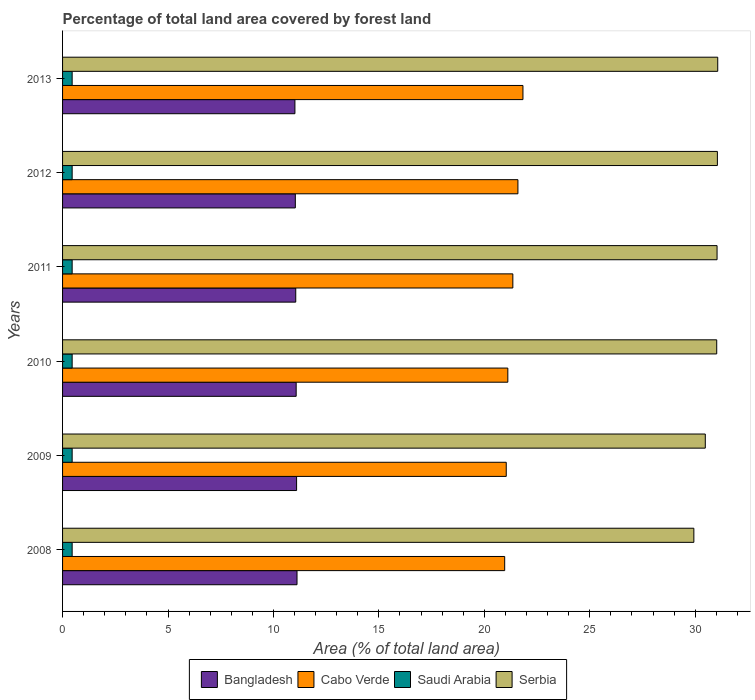How many different coloured bars are there?
Your answer should be compact. 4. How many groups of bars are there?
Provide a succinct answer. 6. Are the number of bars per tick equal to the number of legend labels?
Give a very brief answer. Yes. Are the number of bars on each tick of the Y-axis equal?
Make the answer very short. Yes. How many bars are there on the 5th tick from the top?
Make the answer very short. 4. How many bars are there on the 3rd tick from the bottom?
Keep it short and to the point. 4. In how many cases, is the number of bars for a given year not equal to the number of legend labels?
Your response must be concise. 0. What is the percentage of forest land in Serbia in 2009?
Make the answer very short. 30.48. Across all years, what is the maximum percentage of forest land in Serbia?
Give a very brief answer. 31.07. Across all years, what is the minimum percentage of forest land in Bangladesh?
Provide a succinct answer. 11.02. In which year was the percentage of forest land in Saudi Arabia maximum?
Keep it short and to the point. 2008. In which year was the percentage of forest land in Bangladesh minimum?
Your answer should be compact. 2013. What is the total percentage of forest land in Cabo Verde in the graph?
Ensure brevity in your answer.  127.9. What is the difference between the percentage of forest land in Cabo Verde in 2008 and that in 2011?
Offer a very short reply. -0.39. What is the difference between the percentage of forest land in Serbia in 2009 and the percentage of forest land in Cabo Verde in 2008?
Offer a terse response. 9.51. What is the average percentage of forest land in Bangladesh per year?
Provide a short and direct response. 11.07. In the year 2009, what is the difference between the percentage of forest land in Serbia and percentage of forest land in Cabo Verde?
Provide a short and direct response. 9.44. In how many years, is the percentage of forest land in Bangladesh greater than 20 %?
Your answer should be very brief. 0. What is the ratio of the percentage of forest land in Bangladesh in 2010 to that in 2013?
Your answer should be very brief. 1.01. Is the percentage of forest land in Serbia in 2010 less than that in 2012?
Ensure brevity in your answer.  Yes. What is the difference between the highest and the second highest percentage of forest land in Saudi Arabia?
Your answer should be very brief. 0. What is the difference between the highest and the lowest percentage of forest land in Serbia?
Your answer should be compact. 1.13. In how many years, is the percentage of forest land in Cabo Verde greater than the average percentage of forest land in Cabo Verde taken over all years?
Your answer should be very brief. 3. What does the 1st bar from the top in 2011 represents?
Your answer should be very brief. Serbia. What does the 1st bar from the bottom in 2013 represents?
Ensure brevity in your answer.  Bangladesh. How many years are there in the graph?
Offer a very short reply. 6. Are the values on the major ticks of X-axis written in scientific E-notation?
Your answer should be compact. No. Does the graph contain grids?
Provide a short and direct response. No. How many legend labels are there?
Give a very brief answer. 4. How are the legend labels stacked?
Offer a very short reply. Horizontal. What is the title of the graph?
Offer a very short reply. Percentage of total land area covered by forest land. What is the label or title of the X-axis?
Offer a terse response. Area (% of total land area). What is the label or title of the Y-axis?
Your answer should be compact. Years. What is the Area (% of total land area) of Bangladesh in 2008?
Provide a succinct answer. 11.12. What is the Area (% of total land area) in Cabo Verde in 2008?
Provide a short and direct response. 20.97. What is the Area (% of total land area) of Saudi Arabia in 2008?
Provide a succinct answer. 0.45. What is the Area (% of total land area) of Serbia in 2008?
Ensure brevity in your answer.  29.94. What is the Area (% of total land area) of Bangladesh in 2009?
Provide a succinct answer. 11.1. What is the Area (% of total land area) of Cabo Verde in 2009?
Offer a very short reply. 21.04. What is the Area (% of total land area) of Saudi Arabia in 2009?
Your answer should be compact. 0.45. What is the Area (% of total land area) of Serbia in 2009?
Offer a very short reply. 30.48. What is the Area (% of total land area) in Bangladesh in 2010?
Your response must be concise. 11.08. What is the Area (% of total land area) in Cabo Verde in 2010?
Make the answer very short. 21.11. What is the Area (% of total land area) in Saudi Arabia in 2010?
Provide a succinct answer. 0.45. What is the Area (% of total land area) in Serbia in 2010?
Provide a succinct answer. 31.02. What is the Area (% of total land area) of Bangladesh in 2011?
Provide a succinct answer. 11.06. What is the Area (% of total land area) in Cabo Verde in 2011?
Ensure brevity in your answer.  21.35. What is the Area (% of total land area) of Saudi Arabia in 2011?
Offer a terse response. 0.45. What is the Area (% of total land area) in Serbia in 2011?
Ensure brevity in your answer.  31.04. What is the Area (% of total land area) in Bangladesh in 2012?
Ensure brevity in your answer.  11.04. What is the Area (% of total land area) of Cabo Verde in 2012?
Your answer should be very brief. 21.59. What is the Area (% of total land area) in Saudi Arabia in 2012?
Offer a terse response. 0.45. What is the Area (% of total land area) in Serbia in 2012?
Ensure brevity in your answer.  31.05. What is the Area (% of total land area) in Bangladesh in 2013?
Keep it short and to the point. 11.02. What is the Area (% of total land area) in Cabo Verde in 2013?
Give a very brief answer. 21.83. What is the Area (% of total land area) in Saudi Arabia in 2013?
Make the answer very short. 0.45. What is the Area (% of total land area) in Serbia in 2013?
Provide a succinct answer. 31.07. Across all years, what is the maximum Area (% of total land area) of Bangladesh?
Your answer should be compact. 11.12. Across all years, what is the maximum Area (% of total land area) of Cabo Verde?
Your response must be concise. 21.83. Across all years, what is the maximum Area (% of total land area) of Saudi Arabia?
Keep it short and to the point. 0.45. Across all years, what is the maximum Area (% of total land area) in Serbia?
Give a very brief answer. 31.07. Across all years, what is the minimum Area (% of total land area) in Bangladesh?
Your answer should be compact. 11.02. Across all years, what is the minimum Area (% of total land area) in Cabo Verde?
Make the answer very short. 20.97. Across all years, what is the minimum Area (% of total land area) of Saudi Arabia?
Offer a very short reply. 0.45. Across all years, what is the minimum Area (% of total land area) of Serbia?
Offer a terse response. 29.94. What is the total Area (% of total land area) in Bangladesh in the graph?
Your answer should be very brief. 66.41. What is the total Area (% of total land area) of Cabo Verde in the graph?
Your response must be concise. 127.9. What is the total Area (% of total land area) of Saudi Arabia in the graph?
Keep it short and to the point. 2.73. What is the total Area (% of total land area) in Serbia in the graph?
Your answer should be compact. 184.59. What is the difference between the Area (% of total land area) of Cabo Verde in 2008 and that in 2009?
Ensure brevity in your answer.  -0.07. What is the difference between the Area (% of total land area) of Serbia in 2008 and that in 2009?
Offer a very short reply. -0.54. What is the difference between the Area (% of total land area) of Bangladesh in 2008 and that in 2010?
Your answer should be compact. 0.04. What is the difference between the Area (% of total land area) of Cabo Verde in 2008 and that in 2010?
Keep it short and to the point. -0.15. What is the difference between the Area (% of total land area) of Serbia in 2008 and that in 2010?
Your response must be concise. -1.08. What is the difference between the Area (% of total land area) of Bangladesh in 2008 and that in 2011?
Your answer should be very brief. 0.06. What is the difference between the Area (% of total land area) of Cabo Verde in 2008 and that in 2011?
Your answer should be compact. -0.39. What is the difference between the Area (% of total land area) in Saudi Arabia in 2008 and that in 2011?
Make the answer very short. 0. What is the difference between the Area (% of total land area) in Serbia in 2008 and that in 2011?
Offer a terse response. -1.1. What is the difference between the Area (% of total land area) of Bangladesh in 2008 and that in 2012?
Keep it short and to the point. 0.08. What is the difference between the Area (% of total land area) in Cabo Verde in 2008 and that in 2012?
Your answer should be very brief. -0.63. What is the difference between the Area (% of total land area) in Saudi Arabia in 2008 and that in 2012?
Provide a short and direct response. 0. What is the difference between the Area (% of total land area) in Serbia in 2008 and that in 2012?
Provide a short and direct response. -1.12. What is the difference between the Area (% of total land area) in Bangladesh in 2008 and that in 2013?
Ensure brevity in your answer.  0.1. What is the difference between the Area (% of total land area) in Cabo Verde in 2008 and that in 2013?
Your answer should be compact. -0.87. What is the difference between the Area (% of total land area) in Serbia in 2008 and that in 2013?
Provide a succinct answer. -1.13. What is the difference between the Area (% of total land area) of Bangladesh in 2009 and that in 2010?
Your answer should be very brief. 0.02. What is the difference between the Area (% of total land area) of Cabo Verde in 2009 and that in 2010?
Your answer should be compact. -0.07. What is the difference between the Area (% of total land area) in Serbia in 2009 and that in 2010?
Provide a short and direct response. -0.54. What is the difference between the Area (% of total land area) of Bangladesh in 2009 and that in 2011?
Your answer should be compact. 0.04. What is the difference between the Area (% of total land area) of Cabo Verde in 2009 and that in 2011?
Offer a terse response. -0.31. What is the difference between the Area (% of total land area) of Saudi Arabia in 2009 and that in 2011?
Your answer should be very brief. 0. What is the difference between the Area (% of total land area) in Serbia in 2009 and that in 2011?
Give a very brief answer. -0.56. What is the difference between the Area (% of total land area) in Bangladesh in 2009 and that in 2012?
Provide a succinct answer. 0.06. What is the difference between the Area (% of total land area) of Cabo Verde in 2009 and that in 2012?
Your answer should be very brief. -0.55. What is the difference between the Area (% of total land area) of Serbia in 2009 and that in 2012?
Your response must be concise. -0.57. What is the difference between the Area (% of total land area) in Bangladesh in 2009 and that in 2013?
Keep it short and to the point. 0.08. What is the difference between the Area (% of total land area) in Cabo Verde in 2009 and that in 2013?
Your answer should be very brief. -0.79. What is the difference between the Area (% of total land area) of Serbia in 2009 and that in 2013?
Your answer should be very brief. -0.59. What is the difference between the Area (% of total land area) of Cabo Verde in 2010 and that in 2011?
Offer a very short reply. -0.24. What is the difference between the Area (% of total land area) of Serbia in 2010 and that in 2011?
Your response must be concise. -0.02. What is the difference between the Area (% of total land area) in Bangladesh in 2010 and that in 2012?
Offer a very short reply. 0.04. What is the difference between the Area (% of total land area) in Cabo Verde in 2010 and that in 2012?
Your answer should be very brief. -0.48. What is the difference between the Area (% of total land area) in Serbia in 2010 and that in 2012?
Ensure brevity in your answer.  -0.03. What is the difference between the Area (% of total land area) in Bangladesh in 2010 and that in 2013?
Provide a short and direct response. 0.06. What is the difference between the Area (% of total land area) in Cabo Verde in 2010 and that in 2013?
Make the answer very short. -0.72. What is the difference between the Area (% of total land area) in Saudi Arabia in 2010 and that in 2013?
Your response must be concise. 0. What is the difference between the Area (% of total land area) of Serbia in 2010 and that in 2013?
Keep it short and to the point. -0.05. What is the difference between the Area (% of total land area) of Bangladesh in 2011 and that in 2012?
Offer a very short reply. 0.02. What is the difference between the Area (% of total land area) in Cabo Verde in 2011 and that in 2012?
Provide a short and direct response. -0.24. What is the difference between the Area (% of total land area) of Saudi Arabia in 2011 and that in 2012?
Keep it short and to the point. 0. What is the difference between the Area (% of total land area) of Serbia in 2011 and that in 2012?
Make the answer very short. -0.02. What is the difference between the Area (% of total land area) of Bangladesh in 2011 and that in 2013?
Provide a short and direct response. 0.04. What is the difference between the Area (% of total land area) in Cabo Verde in 2011 and that in 2013?
Your answer should be compact. -0.48. What is the difference between the Area (% of total land area) in Saudi Arabia in 2011 and that in 2013?
Provide a short and direct response. 0. What is the difference between the Area (% of total land area) of Serbia in 2011 and that in 2013?
Offer a terse response. -0.03. What is the difference between the Area (% of total land area) in Bangladesh in 2012 and that in 2013?
Offer a terse response. 0.02. What is the difference between the Area (% of total land area) in Cabo Verde in 2012 and that in 2013?
Your response must be concise. -0.24. What is the difference between the Area (% of total land area) in Saudi Arabia in 2012 and that in 2013?
Your response must be concise. 0. What is the difference between the Area (% of total land area) in Serbia in 2012 and that in 2013?
Your response must be concise. -0.02. What is the difference between the Area (% of total land area) in Bangladesh in 2008 and the Area (% of total land area) in Cabo Verde in 2009?
Give a very brief answer. -9.92. What is the difference between the Area (% of total land area) of Bangladesh in 2008 and the Area (% of total land area) of Saudi Arabia in 2009?
Ensure brevity in your answer.  10.66. What is the difference between the Area (% of total land area) of Bangladesh in 2008 and the Area (% of total land area) of Serbia in 2009?
Your answer should be very brief. -19.36. What is the difference between the Area (% of total land area) of Cabo Verde in 2008 and the Area (% of total land area) of Saudi Arabia in 2009?
Ensure brevity in your answer.  20.51. What is the difference between the Area (% of total land area) in Cabo Verde in 2008 and the Area (% of total land area) in Serbia in 2009?
Offer a very short reply. -9.51. What is the difference between the Area (% of total land area) of Saudi Arabia in 2008 and the Area (% of total land area) of Serbia in 2009?
Keep it short and to the point. -30.02. What is the difference between the Area (% of total land area) of Bangladesh in 2008 and the Area (% of total land area) of Cabo Verde in 2010?
Offer a terse response. -10. What is the difference between the Area (% of total land area) of Bangladesh in 2008 and the Area (% of total land area) of Saudi Arabia in 2010?
Provide a succinct answer. 10.66. What is the difference between the Area (% of total land area) in Bangladesh in 2008 and the Area (% of total land area) in Serbia in 2010?
Provide a succinct answer. -19.9. What is the difference between the Area (% of total land area) of Cabo Verde in 2008 and the Area (% of total land area) of Saudi Arabia in 2010?
Your answer should be very brief. 20.51. What is the difference between the Area (% of total land area) of Cabo Verde in 2008 and the Area (% of total land area) of Serbia in 2010?
Keep it short and to the point. -10.05. What is the difference between the Area (% of total land area) of Saudi Arabia in 2008 and the Area (% of total land area) of Serbia in 2010?
Provide a succinct answer. -30.57. What is the difference between the Area (% of total land area) of Bangladesh in 2008 and the Area (% of total land area) of Cabo Verde in 2011?
Make the answer very short. -10.23. What is the difference between the Area (% of total land area) of Bangladesh in 2008 and the Area (% of total land area) of Saudi Arabia in 2011?
Your answer should be compact. 10.66. What is the difference between the Area (% of total land area) in Bangladesh in 2008 and the Area (% of total land area) in Serbia in 2011?
Ensure brevity in your answer.  -19.92. What is the difference between the Area (% of total land area) in Cabo Verde in 2008 and the Area (% of total land area) in Saudi Arabia in 2011?
Your response must be concise. 20.51. What is the difference between the Area (% of total land area) in Cabo Verde in 2008 and the Area (% of total land area) in Serbia in 2011?
Give a very brief answer. -10.07. What is the difference between the Area (% of total land area) of Saudi Arabia in 2008 and the Area (% of total land area) of Serbia in 2011?
Your answer should be compact. -30.58. What is the difference between the Area (% of total land area) of Bangladesh in 2008 and the Area (% of total land area) of Cabo Verde in 2012?
Your answer should be compact. -10.48. What is the difference between the Area (% of total land area) in Bangladesh in 2008 and the Area (% of total land area) in Saudi Arabia in 2012?
Give a very brief answer. 10.66. What is the difference between the Area (% of total land area) of Bangladesh in 2008 and the Area (% of total land area) of Serbia in 2012?
Your response must be concise. -19.93. What is the difference between the Area (% of total land area) in Cabo Verde in 2008 and the Area (% of total land area) in Saudi Arabia in 2012?
Provide a succinct answer. 20.51. What is the difference between the Area (% of total land area) of Cabo Verde in 2008 and the Area (% of total land area) of Serbia in 2012?
Offer a terse response. -10.09. What is the difference between the Area (% of total land area) in Saudi Arabia in 2008 and the Area (% of total land area) in Serbia in 2012?
Your response must be concise. -30.6. What is the difference between the Area (% of total land area) in Bangladesh in 2008 and the Area (% of total land area) in Cabo Verde in 2013?
Provide a short and direct response. -10.71. What is the difference between the Area (% of total land area) in Bangladesh in 2008 and the Area (% of total land area) in Saudi Arabia in 2013?
Provide a succinct answer. 10.66. What is the difference between the Area (% of total land area) of Bangladesh in 2008 and the Area (% of total land area) of Serbia in 2013?
Offer a terse response. -19.95. What is the difference between the Area (% of total land area) of Cabo Verde in 2008 and the Area (% of total land area) of Saudi Arabia in 2013?
Your response must be concise. 20.51. What is the difference between the Area (% of total land area) of Cabo Verde in 2008 and the Area (% of total land area) of Serbia in 2013?
Provide a short and direct response. -10.1. What is the difference between the Area (% of total land area) of Saudi Arabia in 2008 and the Area (% of total land area) of Serbia in 2013?
Provide a succinct answer. -30.61. What is the difference between the Area (% of total land area) in Bangladesh in 2009 and the Area (% of total land area) in Cabo Verde in 2010?
Provide a succinct answer. -10.02. What is the difference between the Area (% of total land area) in Bangladesh in 2009 and the Area (% of total land area) in Saudi Arabia in 2010?
Make the answer very short. 10.64. What is the difference between the Area (% of total land area) of Bangladesh in 2009 and the Area (% of total land area) of Serbia in 2010?
Make the answer very short. -19.92. What is the difference between the Area (% of total land area) in Cabo Verde in 2009 and the Area (% of total land area) in Saudi Arabia in 2010?
Give a very brief answer. 20.59. What is the difference between the Area (% of total land area) of Cabo Verde in 2009 and the Area (% of total land area) of Serbia in 2010?
Provide a succinct answer. -9.98. What is the difference between the Area (% of total land area) in Saudi Arabia in 2009 and the Area (% of total land area) in Serbia in 2010?
Offer a very short reply. -30.57. What is the difference between the Area (% of total land area) of Bangladesh in 2009 and the Area (% of total land area) of Cabo Verde in 2011?
Give a very brief answer. -10.25. What is the difference between the Area (% of total land area) in Bangladesh in 2009 and the Area (% of total land area) in Saudi Arabia in 2011?
Offer a very short reply. 10.64. What is the difference between the Area (% of total land area) in Bangladesh in 2009 and the Area (% of total land area) in Serbia in 2011?
Your response must be concise. -19.94. What is the difference between the Area (% of total land area) in Cabo Verde in 2009 and the Area (% of total land area) in Saudi Arabia in 2011?
Your answer should be compact. 20.59. What is the difference between the Area (% of total land area) of Cabo Verde in 2009 and the Area (% of total land area) of Serbia in 2011?
Ensure brevity in your answer.  -10. What is the difference between the Area (% of total land area) of Saudi Arabia in 2009 and the Area (% of total land area) of Serbia in 2011?
Your answer should be very brief. -30.58. What is the difference between the Area (% of total land area) in Bangladesh in 2009 and the Area (% of total land area) in Cabo Verde in 2012?
Provide a succinct answer. -10.5. What is the difference between the Area (% of total land area) of Bangladesh in 2009 and the Area (% of total land area) of Saudi Arabia in 2012?
Offer a terse response. 10.64. What is the difference between the Area (% of total land area) in Bangladesh in 2009 and the Area (% of total land area) in Serbia in 2012?
Ensure brevity in your answer.  -19.95. What is the difference between the Area (% of total land area) of Cabo Verde in 2009 and the Area (% of total land area) of Saudi Arabia in 2012?
Your answer should be very brief. 20.59. What is the difference between the Area (% of total land area) in Cabo Verde in 2009 and the Area (% of total land area) in Serbia in 2012?
Offer a very short reply. -10.01. What is the difference between the Area (% of total land area) in Saudi Arabia in 2009 and the Area (% of total land area) in Serbia in 2012?
Provide a succinct answer. -30.6. What is the difference between the Area (% of total land area) in Bangladesh in 2009 and the Area (% of total land area) in Cabo Verde in 2013?
Provide a short and direct response. -10.73. What is the difference between the Area (% of total land area) in Bangladesh in 2009 and the Area (% of total land area) in Saudi Arabia in 2013?
Provide a succinct answer. 10.64. What is the difference between the Area (% of total land area) of Bangladesh in 2009 and the Area (% of total land area) of Serbia in 2013?
Offer a very short reply. -19.97. What is the difference between the Area (% of total land area) in Cabo Verde in 2009 and the Area (% of total land area) in Saudi Arabia in 2013?
Provide a short and direct response. 20.59. What is the difference between the Area (% of total land area) of Cabo Verde in 2009 and the Area (% of total land area) of Serbia in 2013?
Keep it short and to the point. -10.03. What is the difference between the Area (% of total land area) of Saudi Arabia in 2009 and the Area (% of total land area) of Serbia in 2013?
Make the answer very short. -30.61. What is the difference between the Area (% of total land area) in Bangladesh in 2010 and the Area (% of total land area) in Cabo Verde in 2011?
Ensure brevity in your answer.  -10.27. What is the difference between the Area (% of total land area) in Bangladesh in 2010 and the Area (% of total land area) in Saudi Arabia in 2011?
Make the answer very short. 10.62. What is the difference between the Area (% of total land area) of Bangladesh in 2010 and the Area (% of total land area) of Serbia in 2011?
Offer a terse response. -19.96. What is the difference between the Area (% of total land area) of Cabo Verde in 2010 and the Area (% of total land area) of Saudi Arabia in 2011?
Make the answer very short. 20.66. What is the difference between the Area (% of total land area) in Cabo Verde in 2010 and the Area (% of total land area) in Serbia in 2011?
Provide a short and direct response. -9.92. What is the difference between the Area (% of total land area) of Saudi Arabia in 2010 and the Area (% of total land area) of Serbia in 2011?
Give a very brief answer. -30.58. What is the difference between the Area (% of total land area) in Bangladesh in 2010 and the Area (% of total land area) in Cabo Verde in 2012?
Keep it short and to the point. -10.52. What is the difference between the Area (% of total land area) in Bangladesh in 2010 and the Area (% of total land area) in Saudi Arabia in 2012?
Provide a short and direct response. 10.62. What is the difference between the Area (% of total land area) in Bangladesh in 2010 and the Area (% of total land area) in Serbia in 2012?
Your response must be concise. -19.97. What is the difference between the Area (% of total land area) in Cabo Verde in 2010 and the Area (% of total land area) in Saudi Arabia in 2012?
Give a very brief answer. 20.66. What is the difference between the Area (% of total land area) of Cabo Verde in 2010 and the Area (% of total land area) of Serbia in 2012?
Provide a short and direct response. -9.94. What is the difference between the Area (% of total land area) in Saudi Arabia in 2010 and the Area (% of total land area) in Serbia in 2012?
Offer a very short reply. -30.6. What is the difference between the Area (% of total land area) in Bangladesh in 2010 and the Area (% of total land area) in Cabo Verde in 2013?
Your answer should be very brief. -10.75. What is the difference between the Area (% of total land area) of Bangladesh in 2010 and the Area (% of total land area) of Saudi Arabia in 2013?
Your answer should be compact. 10.62. What is the difference between the Area (% of total land area) in Bangladesh in 2010 and the Area (% of total land area) in Serbia in 2013?
Offer a very short reply. -19.99. What is the difference between the Area (% of total land area) in Cabo Verde in 2010 and the Area (% of total land area) in Saudi Arabia in 2013?
Provide a succinct answer. 20.66. What is the difference between the Area (% of total land area) in Cabo Verde in 2010 and the Area (% of total land area) in Serbia in 2013?
Provide a short and direct response. -9.95. What is the difference between the Area (% of total land area) in Saudi Arabia in 2010 and the Area (% of total land area) in Serbia in 2013?
Provide a succinct answer. -30.61. What is the difference between the Area (% of total land area) in Bangladesh in 2011 and the Area (% of total land area) in Cabo Verde in 2012?
Make the answer very short. -10.54. What is the difference between the Area (% of total land area) in Bangladesh in 2011 and the Area (% of total land area) in Saudi Arabia in 2012?
Your answer should be very brief. 10.6. What is the difference between the Area (% of total land area) of Bangladesh in 2011 and the Area (% of total land area) of Serbia in 2012?
Make the answer very short. -19.99. What is the difference between the Area (% of total land area) in Cabo Verde in 2011 and the Area (% of total land area) in Saudi Arabia in 2012?
Your answer should be compact. 20.9. What is the difference between the Area (% of total land area) of Cabo Verde in 2011 and the Area (% of total land area) of Serbia in 2012?
Your response must be concise. -9.7. What is the difference between the Area (% of total land area) of Saudi Arabia in 2011 and the Area (% of total land area) of Serbia in 2012?
Make the answer very short. -30.6. What is the difference between the Area (% of total land area) in Bangladesh in 2011 and the Area (% of total land area) in Cabo Verde in 2013?
Give a very brief answer. -10.77. What is the difference between the Area (% of total land area) in Bangladesh in 2011 and the Area (% of total land area) in Saudi Arabia in 2013?
Make the answer very short. 10.6. What is the difference between the Area (% of total land area) of Bangladesh in 2011 and the Area (% of total land area) of Serbia in 2013?
Ensure brevity in your answer.  -20.01. What is the difference between the Area (% of total land area) of Cabo Verde in 2011 and the Area (% of total land area) of Saudi Arabia in 2013?
Keep it short and to the point. 20.9. What is the difference between the Area (% of total land area) in Cabo Verde in 2011 and the Area (% of total land area) in Serbia in 2013?
Your answer should be very brief. -9.72. What is the difference between the Area (% of total land area) of Saudi Arabia in 2011 and the Area (% of total land area) of Serbia in 2013?
Provide a succinct answer. -30.61. What is the difference between the Area (% of total land area) of Bangladesh in 2012 and the Area (% of total land area) of Cabo Verde in 2013?
Provide a short and direct response. -10.79. What is the difference between the Area (% of total land area) in Bangladesh in 2012 and the Area (% of total land area) in Saudi Arabia in 2013?
Keep it short and to the point. 10.58. What is the difference between the Area (% of total land area) of Bangladesh in 2012 and the Area (% of total land area) of Serbia in 2013?
Offer a very short reply. -20.03. What is the difference between the Area (% of total land area) in Cabo Verde in 2012 and the Area (% of total land area) in Saudi Arabia in 2013?
Provide a short and direct response. 21.14. What is the difference between the Area (% of total land area) in Cabo Verde in 2012 and the Area (% of total land area) in Serbia in 2013?
Your answer should be compact. -9.47. What is the difference between the Area (% of total land area) in Saudi Arabia in 2012 and the Area (% of total land area) in Serbia in 2013?
Your answer should be compact. -30.61. What is the average Area (% of total land area) in Bangladesh per year?
Offer a terse response. 11.07. What is the average Area (% of total land area) of Cabo Verde per year?
Your answer should be compact. 21.32. What is the average Area (% of total land area) of Saudi Arabia per year?
Ensure brevity in your answer.  0.45. What is the average Area (% of total land area) of Serbia per year?
Ensure brevity in your answer.  30.76. In the year 2008, what is the difference between the Area (% of total land area) in Bangladesh and Area (% of total land area) in Cabo Verde?
Ensure brevity in your answer.  -9.85. In the year 2008, what is the difference between the Area (% of total land area) in Bangladesh and Area (% of total land area) in Saudi Arabia?
Keep it short and to the point. 10.66. In the year 2008, what is the difference between the Area (% of total land area) in Bangladesh and Area (% of total land area) in Serbia?
Provide a succinct answer. -18.82. In the year 2008, what is the difference between the Area (% of total land area) of Cabo Verde and Area (% of total land area) of Saudi Arabia?
Make the answer very short. 20.51. In the year 2008, what is the difference between the Area (% of total land area) of Cabo Verde and Area (% of total land area) of Serbia?
Provide a short and direct response. -8.97. In the year 2008, what is the difference between the Area (% of total land area) of Saudi Arabia and Area (% of total land area) of Serbia?
Offer a terse response. -29.48. In the year 2009, what is the difference between the Area (% of total land area) of Bangladesh and Area (% of total land area) of Cabo Verde?
Make the answer very short. -9.94. In the year 2009, what is the difference between the Area (% of total land area) of Bangladesh and Area (% of total land area) of Saudi Arabia?
Offer a very short reply. 10.64. In the year 2009, what is the difference between the Area (% of total land area) of Bangladesh and Area (% of total land area) of Serbia?
Your response must be concise. -19.38. In the year 2009, what is the difference between the Area (% of total land area) in Cabo Verde and Area (% of total land area) in Saudi Arabia?
Offer a very short reply. 20.59. In the year 2009, what is the difference between the Area (% of total land area) in Cabo Verde and Area (% of total land area) in Serbia?
Make the answer very short. -9.44. In the year 2009, what is the difference between the Area (% of total land area) in Saudi Arabia and Area (% of total land area) in Serbia?
Offer a very short reply. -30.02. In the year 2010, what is the difference between the Area (% of total land area) in Bangladesh and Area (% of total land area) in Cabo Verde?
Offer a terse response. -10.04. In the year 2010, what is the difference between the Area (% of total land area) in Bangladesh and Area (% of total land area) in Saudi Arabia?
Make the answer very short. 10.62. In the year 2010, what is the difference between the Area (% of total land area) in Bangladesh and Area (% of total land area) in Serbia?
Offer a terse response. -19.94. In the year 2010, what is the difference between the Area (% of total land area) in Cabo Verde and Area (% of total land area) in Saudi Arabia?
Provide a short and direct response. 20.66. In the year 2010, what is the difference between the Area (% of total land area) of Cabo Verde and Area (% of total land area) of Serbia?
Your response must be concise. -9.91. In the year 2010, what is the difference between the Area (% of total land area) of Saudi Arabia and Area (% of total land area) of Serbia?
Give a very brief answer. -30.57. In the year 2011, what is the difference between the Area (% of total land area) in Bangladesh and Area (% of total land area) in Cabo Verde?
Your answer should be compact. -10.29. In the year 2011, what is the difference between the Area (% of total land area) of Bangladesh and Area (% of total land area) of Saudi Arabia?
Make the answer very short. 10.6. In the year 2011, what is the difference between the Area (% of total land area) in Bangladesh and Area (% of total land area) in Serbia?
Offer a terse response. -19.98. In the year 2011, what is the difference between the Area (% of total land area) in Cabo Verde and Area (% of total land area) in Saudi Arabia?
Ensure brevity in your answer.  20.9. In the year 2011, what is the difference between the Area (% of total land area) in Cabo Verde and Area (% of total land area) in Serbia?
Provide a short and direct response. -9.68. In the year 2011, what is the difference between the Area (% of total land area) in Saudi Arabia and Area (% of total land area) in Serbia?
Give a very brief answer. -30.58. In the year 2012, what is the difference between the Area (% of total land area) in Bangladesh and Area (% of total land area) in Cabo Verde?
Make the answer very short. -10.56. In the year 2012, what is the difference between the Area (% of total land area) in Bangladesh and Area (% of total land area) in Saudi Arabia?
Provide a short and direct response. 10.58. In the year 2012, what is the difference between the Area (% of total land area) in Bangladesh and Area (% of total land area) in Serbia?
Keep it short and to the point. -20.01. In the year 2012, what is the difference between the Area (% of total land area) of Cabo Verde and Area (% of total land area) of Saudi Arabia?
Offer a very short reply. 21.14. In the year 2012, what is the difference between the Area (% of total land area) in Cabo Verde and Area (% of total land area) in Serbia?
Provide a succinct answer. -9.46. In the year 2012, what is the difference between the Area (% of total land area) of Saudi Arabia and Area (% of total land area) of Serbia?
Make the answer very short. -30.6. In the year 2013, what is the difference between the Area (% of total land area) in Bangladesh and Area (% of total land area) in Cabo Verde?
Your answer should be compact. -10.81. In the year 2013, what is the difference between the Area (% of total land area) of Bangladesh and Area (% of total land area) of Saudi Arabia?
Your answer should be very brief. 10.56. In the year 2013, what is the difference between the Area (% of total land area) of Bangladesh and Area (% of total land area) of Serbia?
Provide a short and direct response. -20.05. In the year 2013, what is the difference between the Area (% of total land area) in Cabo Verde and Area (% of total land area) in Saudi Arabia?
Offer a very short reply. 21.38. In the year 2013, what is the difference between the Area (% of total land area) in Cabo Verde and Area (% of total land area) in Serbia?
Provide a succinct answer. -9.24. In the year 2013, what is the difference between the Area (% of total land area) in Saudi Arabia and Area (% of total land area) in Serbia?
Your response must be concise. -30.61. What is the ratio of the Area (% of total land area) in Bangladesh in 2008 to that in 2009?
Give a very brief answer. 1. What is the ratio of the Area (% of total land area) in Cabo Verde in 2008 to that in 2009?
Give a very brief answer. 1. What is the ratio of the Area (% of total land area) in Saudi Arabia in 2008 to that in 2009?
Provide a succinct answer. 1. What is the ratio of the Area (% of total land area) in Serbia in 2008 to that in 2009?
Your answer should be very brief. 0.98. What is the ratio of the Area (% of total land area) of Cabo Verde in 2008 to that in 2010?
Your answer should be compact. 0.99. What is the ratio of the Area (% of total land area) of Saudi Arabia in 2008 to that in 2010?
Keep it short and to the point. 1. What is the ratio of the Area (% of total land area) in Serbia in 2008 to that in 2010?
Offer a very short reply. 0.97. What is the ratio of the Area (% of total land area) of Bangladesh in 2008 to that in 2011?
Give a very brief answer. 1.01. What is the ratio of the Area (% of total land area) of Cabo Verde in 2008 to that in 2011?
Give a very brief answer. 0.98. What is the ratio of the Area (% of total land area) of Saudi Arabia in 2008 to that in 2011?
Your answer should be very brief. 1. What is the ratio of the Area (% of total land area) of Serbia in 2008 to that in 2011?
Offer a very short reply. 0.96. What is the ratio of the Area (% of total land area) in Bangladesh in 2008 to that in 2012?
Make the answer very short. 1.01. What is the ratio of the Area (% of total land area) of Cabo Verde in 2008 to that in 2012?
Make the answer very short. 0.97. What is the ratio of the Area (% of total land area) in Saudi Arabia in 2008 to that in 2012?
Your response must be concise. 1. What is the ratio of the Area (% of total land area) of Serbia in 2008 to that in 2012?
Provide a short and direct response. 0.96. What is the ratio of the Area (% of total land area) of Bangladesh in 2008 to that in 2013?
Give a very brief answer. 1.01. What is the ratio of the Area (% of total land area) in Cabo Verde in 2008 to that in 2013?
Ensure brevity in your answer.  0.96. What is the ratio of the Area (% of total land area) in Saudi Arabia in 2008 to that in 2013?
Keep it short and to the point. 1. What is the ratio of the Area (% of total land area) of Serbia in 2008 to that in 2013?
Offer a terse response. 0.96. What is the ratio of the Area (% of total land area) of Saudi Arabia in 2009 to that in 2010?
Make the answer very short. 1. What is the ratio of the Area (% of total land area) of Serbia in 2009 to that in 2010?
Provide a short and direct response. 0.98. What is the ratio of the Area (% of total land area) in Cabo Verde in 2009 to that in 2011?
Keep it short and to the point. 0.99. What is the ratio of the Area (% of total land area) in Bangladesh in 2009 to that in 2012?
Your answer should be very brief. 1.01. What is the ratio of the Area (% of total land area) of Cabo Verde in 2009 to that in 2012?
Give a very brief answer. 0.97. What is the ratio of the Area (% of total land area) in Serbia in 2009 to that in 2012?
Provide a short and direct response. 0.98. What is the ratio of the Area (% of total land area) of Bangladesh in 2009 to that in 2013?
Make the answer very short. 1.01. What is the ratio of the Area (% of total land area) of Cabo Verde in 2009 to that in 2013?
Make the answer very short. 0.96. What is the ratio of the Area (% of total land area) of Saudi Arabia in 2009 to that in 2013?
Offer a terse response. 1. What is the ratio of the Area (% of total land area) in Bangladesh in 2010 to that in 2011?
Your answer should be very brief. 1. What is the ratio of the Area (% of total land area) of Serbia in 2010 to that in 2011?
Your response must be concise. 1. What is the ratio of the Area (% of total land area) in Cabo Verde in 2010 to that in 2012?
Give a very brief answer. 0.98. What is the ratio of the Area (% of total land area) of Saudi Arabia in 2010 to that in 2012?
Make the answer very short. 1. What is the ratio of the Area (% of total land area) of Bangladesh in 2010 to that in 2013?
Ensure brevity in your answer.  1.01. What is the ratio of the Area (% of total land area) in Cabo Verde in 2010 to that in 2013?
Your response must be concise. 0.97. What is the ratio of the Area (% of total land area) in Serbia in 2010 to that in 2013?
Your answer should be very brief. 1. What is the ratio of the Area (% of total land area) of Bangladesh in 2011 to that in 2012?
Give a very brief answer. 1. What is the ratio of the Area (% of total land area) of Cabo Verde in 2011 to that in 2012?
Your answer should be compact. 0.99. What is the ratio of the Area (% of total land area) in Saudi Arabia in 2011 to that in 2012?
Ensure brevity in your answer.  1. What is the ratio of the Area (% of total land area) in Serbia in 2011 to that in 2012?
Give a very brief answer. 1. What is the ratio of the Area (% of total land area) in Cabo Verde in 2011 to that in 2013?
Provide a succinct answer. 0.98. What is the ratio of the Area (% of total land area) in Saudi Arabia in 2011 to that in 2013?
Keep it short and to the point. 1. What is the ratio of the Area (% of total land area) of Serbia in 2011 to that in 2013?
Provide a succinct answer. 1. What is the ratio of the Area (% of total land area) in Bangladesh in 2012 to that in 2013?
Provide a succinct answer. 1. What is the ratio of the Area (% of total land area) in Saudi Arabia in 2012 to that in 2013?
Keep it short and to the point. 1. What is the ratio of the Area (% of total land area) of Serbia in 2012 to that in 2013?
Offer a very short reply. 1. What is the difference between the highest and the second highest Area (% of total land area) in Bangladesh?
Offer a terse response. 0.02. What is the difference between the highest and the second highest Area (% of total land area) of Cabo Verde?
Your answer should be compact. 0.24. What is the difference between the highest and the second highest Area (% of total land area) of Saudi Arabia?
Make the answer very short. 0. What is the difference between the highest and the second highest Area (% of total land area) of Serbia?
Give a very brief answer. 0.02. What is the difference between the highest and the lowest Area (% of total land area) of Bangladesh?
Your answer should be compact. 0.1. What is the difference between the highest and the lowest Area (% of total land area) of Cabo Verde?
Offer a very short reply. 0.87. What is the difference between the highest and the lowest Area (% of total land area) in Saudi Arabia?
Keep it short and to the point. 0. What is the difference between the highest and the lowest Area (% of total land area) of Serbia?
Offer a very short reply. 1.13. 